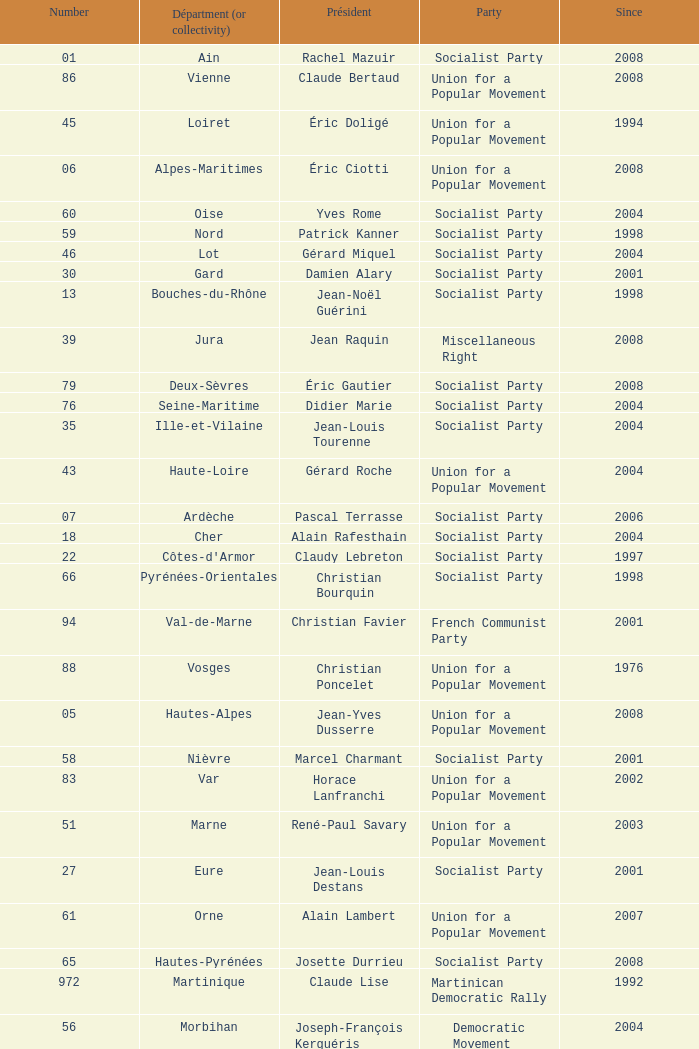Who is the president representing the Creuse department? Jean-Jacques Lozach. 